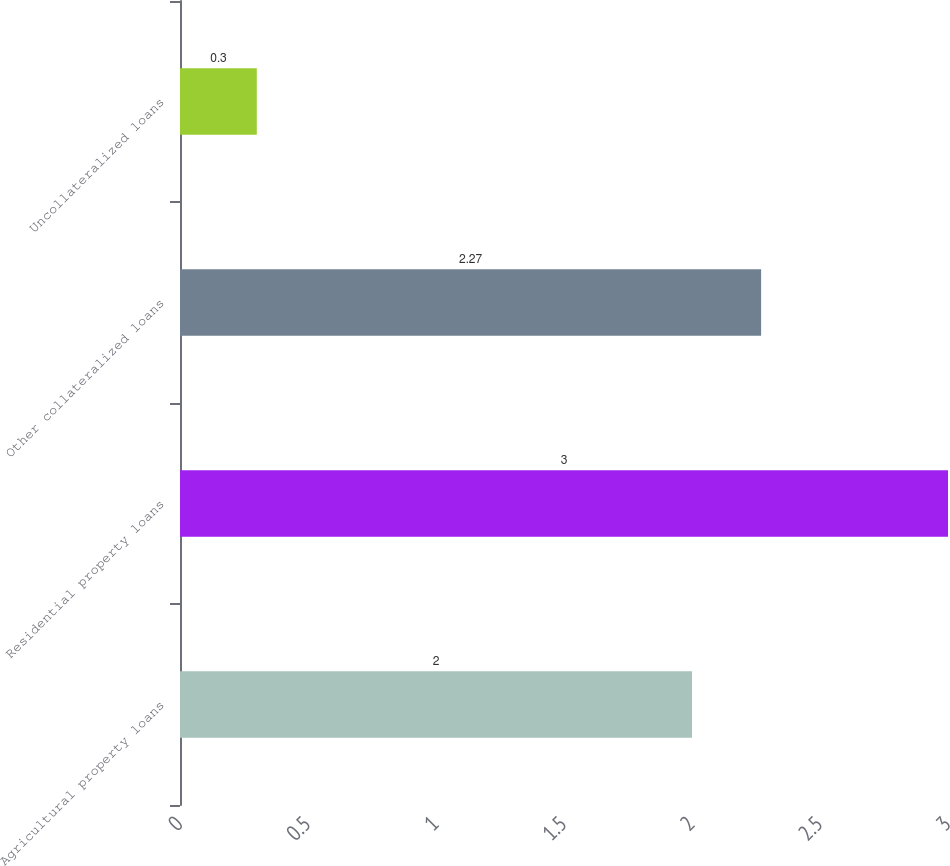Convert chart to OTSL. <chart><loc_0><loc_0><loc_500><loc_500><bar_chart><fcel>Agricultural property loans<fcel>Residential property loans<fcel>Other collateralized loans<fcel>Uncollateralized loans<nl><fcel>2<fcel>3<fcel>2.27<fcel>0.3<nl></chart> 